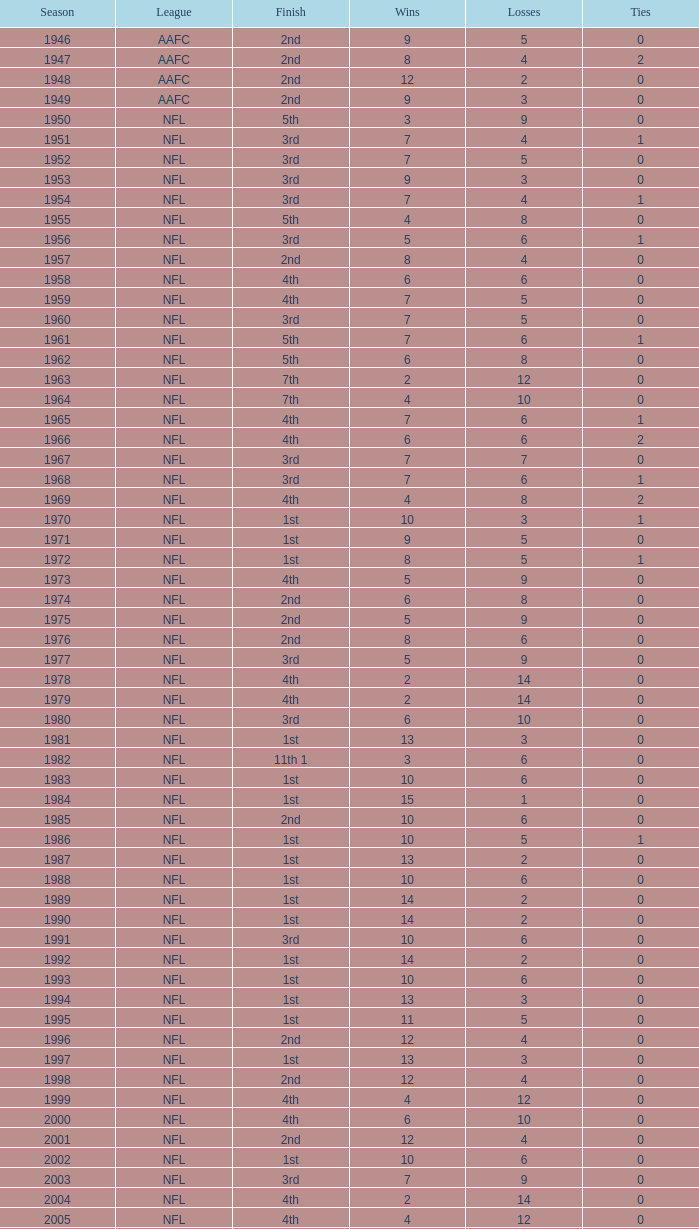Which league witnessed a team ending up in 2nd place with three defeats? AAFC. 